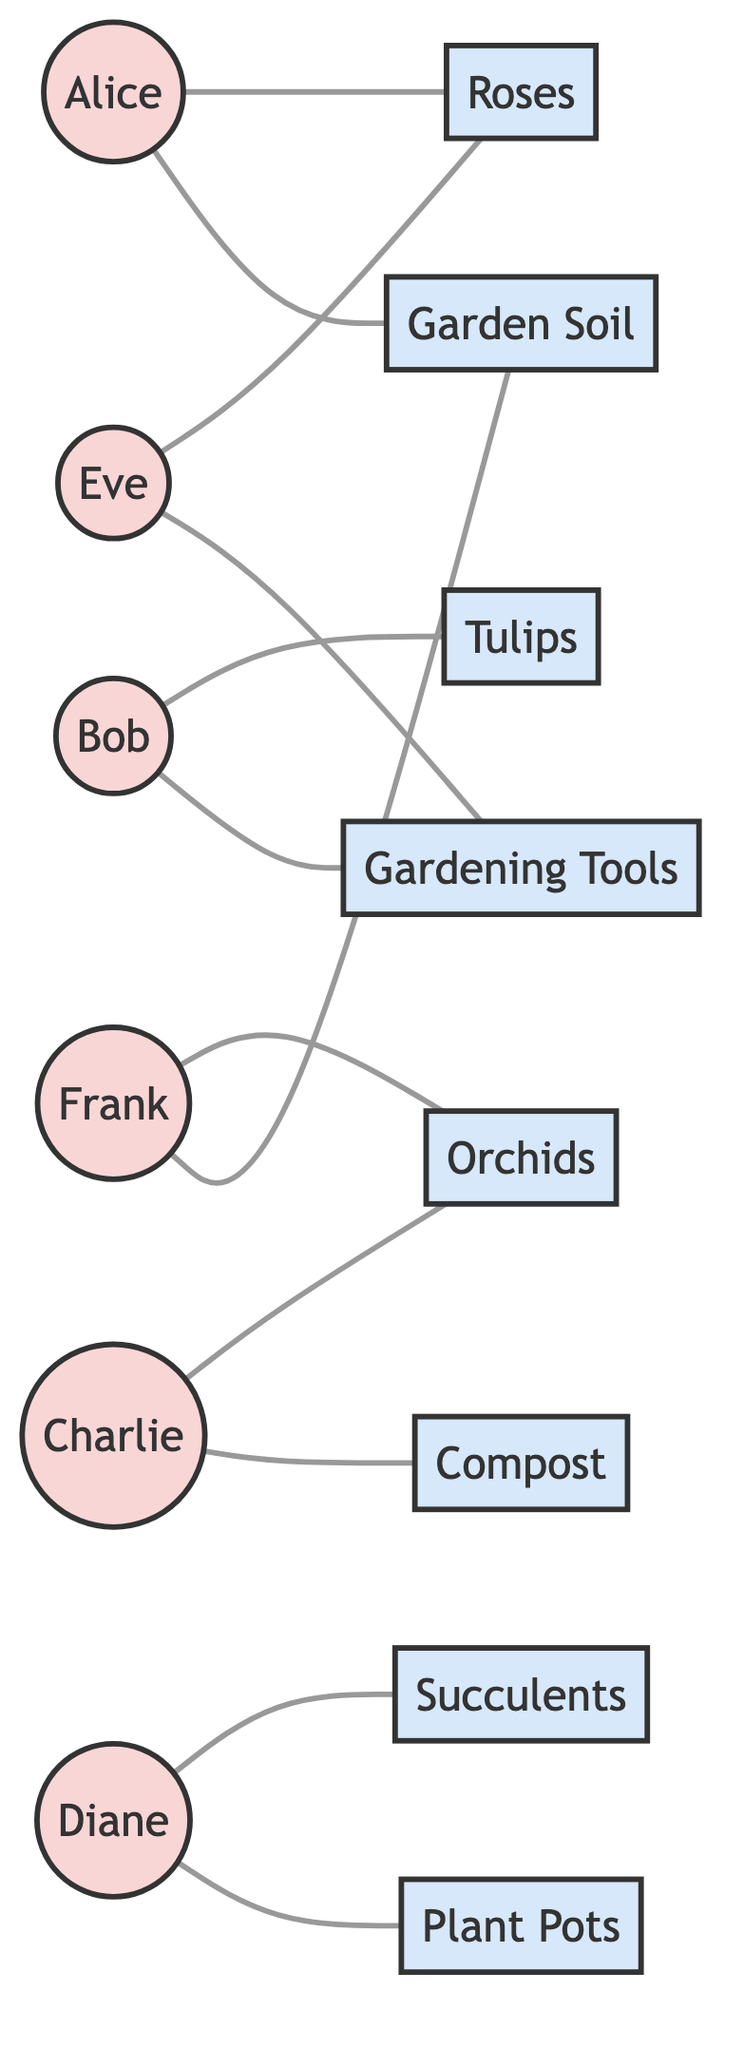What are the total number of customers in the diagram? The diagram includes six individual customer nodes: Alice, Bob, Charlie, Diane, Eve, and Frank. Therefore, we count these nodes to find the total number of customers, which is 6.
Answer: 6 Which product is purchased by both Alice and Eve? The diagram connects Alice to the Roses node and also connects Eve to the Roses node. Hence, both customers have purchased Roses.
Answer: Roses How many products are listed in the diagram? The diagram represents a total of eight unique product nodes: Roses, Garden Soil, Tulips, Gardening Tools, Orchids, Compost, Succulents, and Plant Pots. Counting them results in 8 products.
Answer: 8 Which customer purchased the most products? Analyzing the connections, Alice and Eve purchased 2 products each, Bob purchased 2, Charlie purchased 2, Diane purchased 2, and Frank purchased 2. Since all customers purchased the same maximum of 2 products, it can be said all.
Answer: All How many different products did Frank purchase? The diagram shows that Frank is connected to two products: Orchids and Garden Soil. This means Frank has made 2 distinct purchases.
Answer: 2 Which product is exclusively purchased by Diane? Looking at Diane’s connections, she is linked to Succulents and Plant Pots; the plants linked to other customers show that neither of these products is purchased by anyone else. Hence, both products can be characterized as exclusive to Diane.
Answer: Succulents and Plant Pots Which two customers purchased Gardening Tools? By reviewing the diagram, Bob and Eve are connected to the Gardening Tools product, indicating that both of these customers have made purchases of this product.
Answer: Bob and Eve Is there a product that is purchased by only one customer? The products linked to customers are examined; checking the links, all products have at least one other customer (like Gardening Tools being shared by Bob and Eve). Thus, it is determined that there is no product uniquely purchased.
Answer: No Which customer shares their purchases with the highest number of others? Each customer’s connections indicate how many other customers they share purchases with. Analyzing all connections, we find that Alice and Eve both share Roses with each other and share Gardening Tools with one other customer. Overall, they share with the widest selection.
Answer: Alice and Eve 